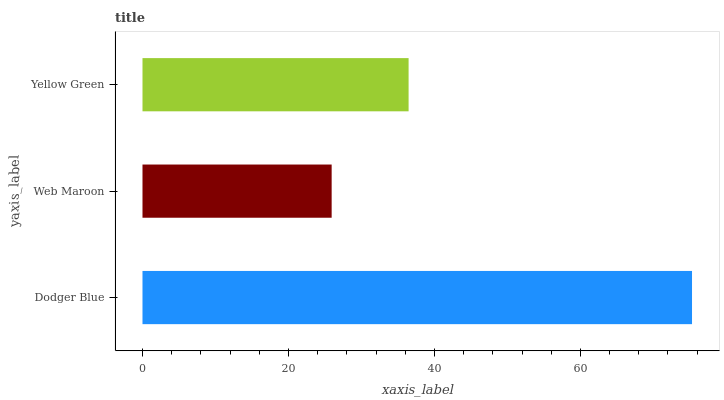Is Web Maroon the minimum?
Answer yes or no. Yes. Is Dodger Blue the maximum?
Answer yes or no. Yes. Is Yellow Green the minimum?
Answer yes or no. No. Is Yellow Green the maximum?
Answer yes or no. No. Is Yellow Green greater than Web Maroon?
Answer yes or no. Yes. Is Web Maroon less than Yellow Green?
Answer yes or no. Yes. Is Web Maroon greater than Yellow Green?
Answer yes or no. No. Is Yellow Green less than Web Maroon?
Answer yes or no. No. Is Yellow Green the high median?
Answer yes or no. Yes. Is Yellow Green the low median?
Answer yes or no. Yes. Is Dodger Blue the high median?
Answer yes or no. No. Is Web Maroon the low median?
Answer yes or no. No. 